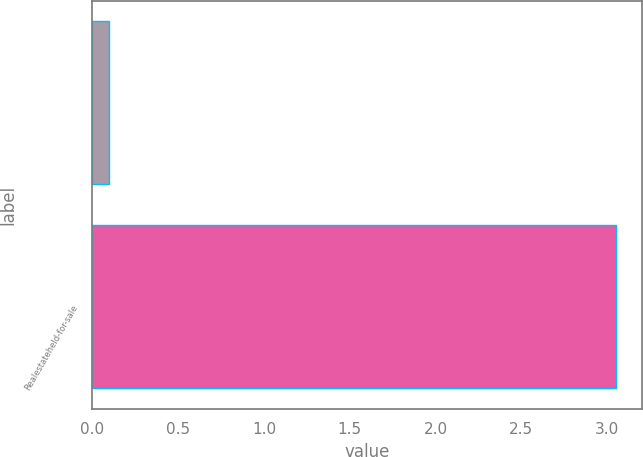Convert chart to OTSL. <chart><loc_0><loc_0><loc_500><loc_500><bar_chart><ecel><fcel>Realestateheld-for-sale<nl><fcel>0.1<fcel>3.05<nl></chart> 